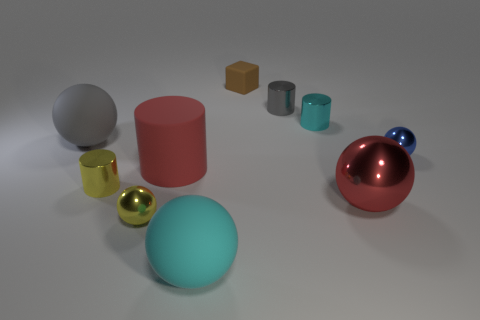Are there any metallic objects that have the same color as the big cylinder?
Provide a succinct answer. Yes. The gray metallic thing is what shape?
Make the answer very short. Cylinder. Does the small block have the same color as the tiny cylinder left of the large red matte cylinder?
Offer a very short reply. No. Is the number of tiny shiny things behind the tiny yellow shiny sphere the same as the number of big red metal spheres?
Make the answer very short. No. What number of other rubber cylinders have the same size as the red matte cylinder?
Provide a short and direct response. 0. What shape is the matte object that is the same color as the big metal ball?
Offer a terse response. Cylinder. Are any tiny green things visible?
Offer a very short reply. No. There is a big red object left of the small block; is its shape the same as the cyan thing that is on the right side of the small gray object?
Your answer should be compact. Yes. What number of large things are either brown matte blocks or matte objects?
Keep it short and to the point. 3. There is a big thing that is the same material as the yellow ball; what is its shape?
Your response must be concise. Sphere. 